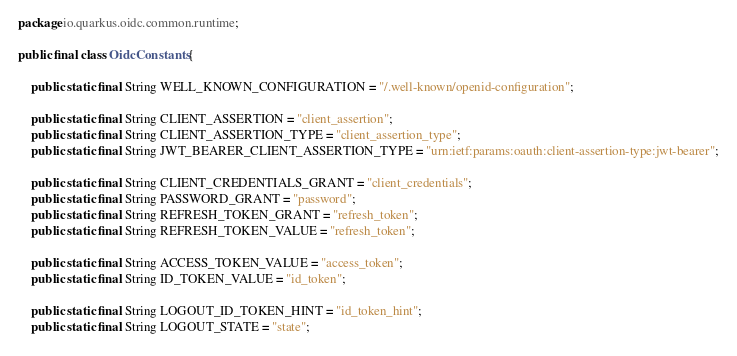<code> <loc_0><loc_0><loc_500><loc_500><_Java_>package io.quarkus.oidc.common.runtime;

public final class OidcConstants {

    public static final String WELL_KNOWN_CONFIGURATION = "/.well-known/openid-configuration";

    public static final String CLIENT_ASSERTION = "client_assertion";
    public static final String CLIENT_ASSERTION_TYPE = "client_assertion_type";
    public static final String JWT_BEARER_CLIENT_ASSERTION_TYPE = "urn:ietf:params:oauth:client-assertion-type:jwt-bearer";

    public static final String CLIENT_CREDENTIALS_GRANT = "client_credentials";
    public static final String PASSWORD_GRANT = "password";
    public static final String REFRESH_TOKEN_GRANT = "refresh_token";
    public static final String REFRESH_TOKEN_VALUE = "refresh_token";

    public static final String ACCESS_TOKEN_VALUE = "access_token";
    public static final String ID_TOKEN_VALUE = "id_token";

    public static final String LOGOUT_ID_TOKEN_HINT = "id_token_hint";
    public static final String LOGOUT_STATE = "state";</code> 